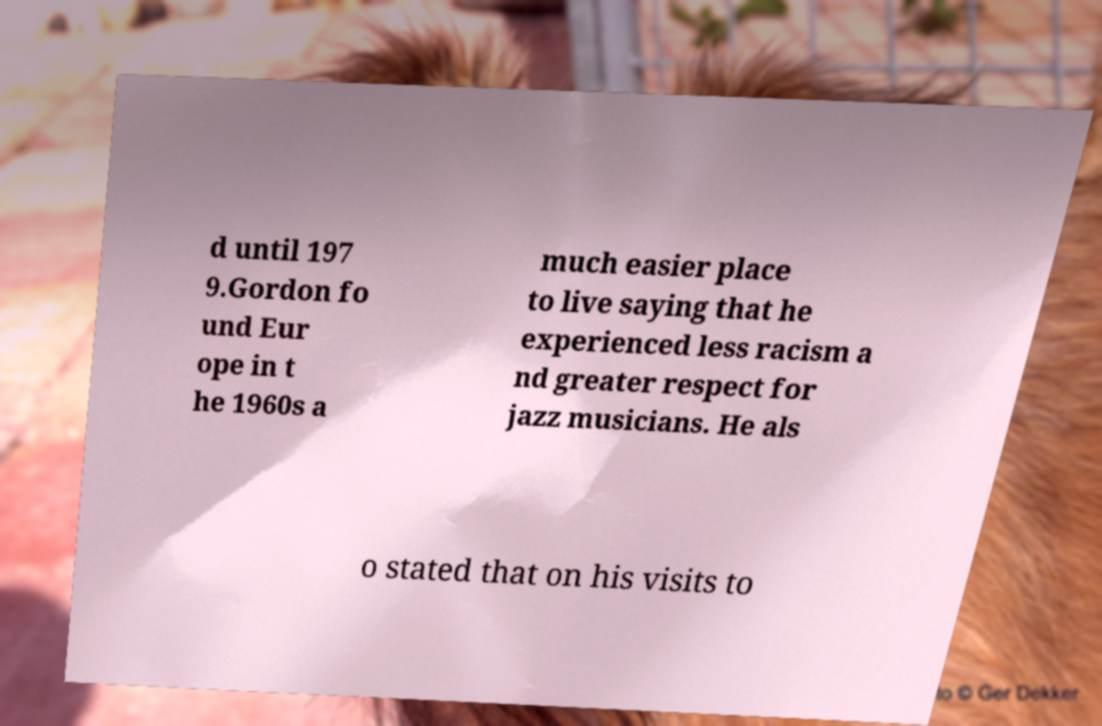Could you assist in decoding the text presented in this image and type it out clearly? d until 197 9.Gordon fo und Eur ope in t he 1960s a much easier place to live saying that he experienced less racism a nd greater respect for jazz musicians. He als o stated that on his visits to 